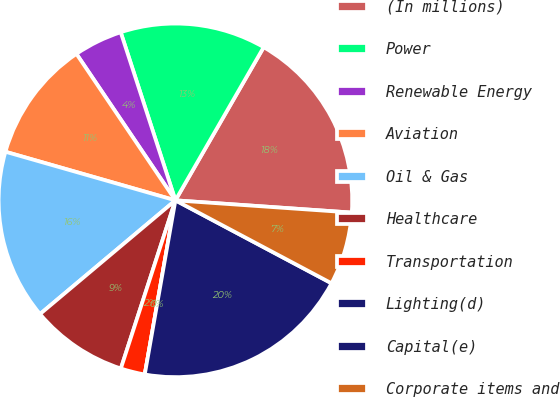Convert chart. <chart><loc_0><loc_0><loc_500><loc_500><pie_chart><fcel>(In millions)<fcel>Power<fcel>Renewable Energy<fcel>Aviation<fcel>Oil & Gas<fcel>Healthcare<fcel>Transportation<fcel>Lighting(d)<fcel>Capital(e)<fcel>Corporate items and<nl><fcel>17.78%<fcel>13.33%<fcel>4.45%<fcel>11.11%<fcel>15.55%<fcel>8.89%<fcel>2.22%<fcel>0.0%<fcel>20.0%<fcel>6.67%<nl></chart> 